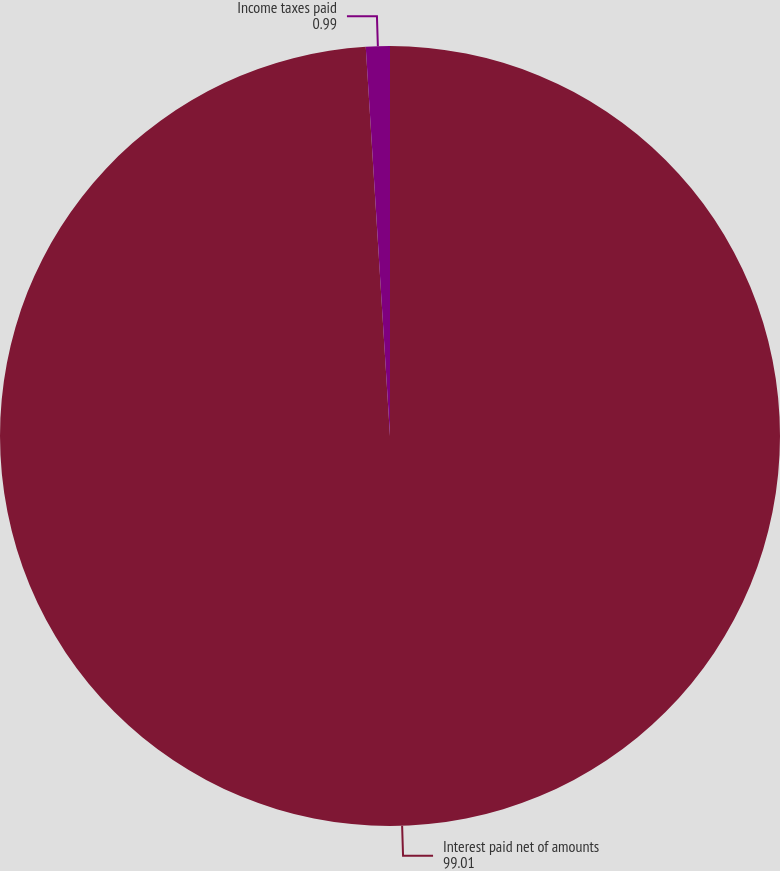<chart> <loc_0><loc_0><loc_500><loc_500><pie_chart><fcel>Interest paid net of amounts<fcel>Income taxes paid<nl><fcel>99.01%<fcel>0.99%<nl></chart> 